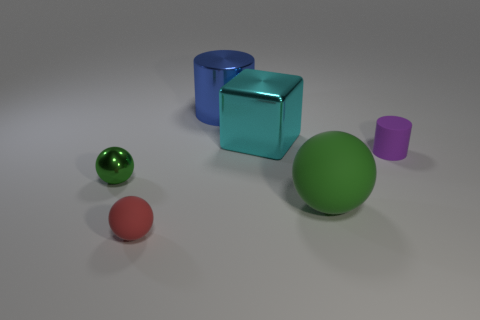There is a tiny sphere that is the same color as the large sphere; what material is it?
Your response must be concise. Metal. What is the size of the red thing that is on the right side of the sphere to the left of the matte thing that is left of the big cyan metallic cube?
Offer a very short reply. Small. What is the size of the green ball right of the tiny shiny object?
Your answer should be very brief. Large. How many things are large yellow matte cubes or small objects that are to the left of the purple thing?
Provide a succinct answer. 2. How many other things are the same size as the green metal ball?
Your answer should be very brief. 2. There is another thing that is the same shape as the blue metallic object; what material is it?
Provide a succinct answer. Rubber. Is the number of red rubber spheres that are behind the big rubber ball greater than the number of green metallic cubes?
Give a very brief answer. No. Is there any other thing that has the same color as the small rubber ball?
Give a very brief answer. No. What is the shape of the purple thing that is the same material as the big sphere?
Your response must be concise. Cylinder. Is the material of the green sphere that is to the right of the big blue cylinder the same as the blue cylinder?
Keep it short and to the point. No. 